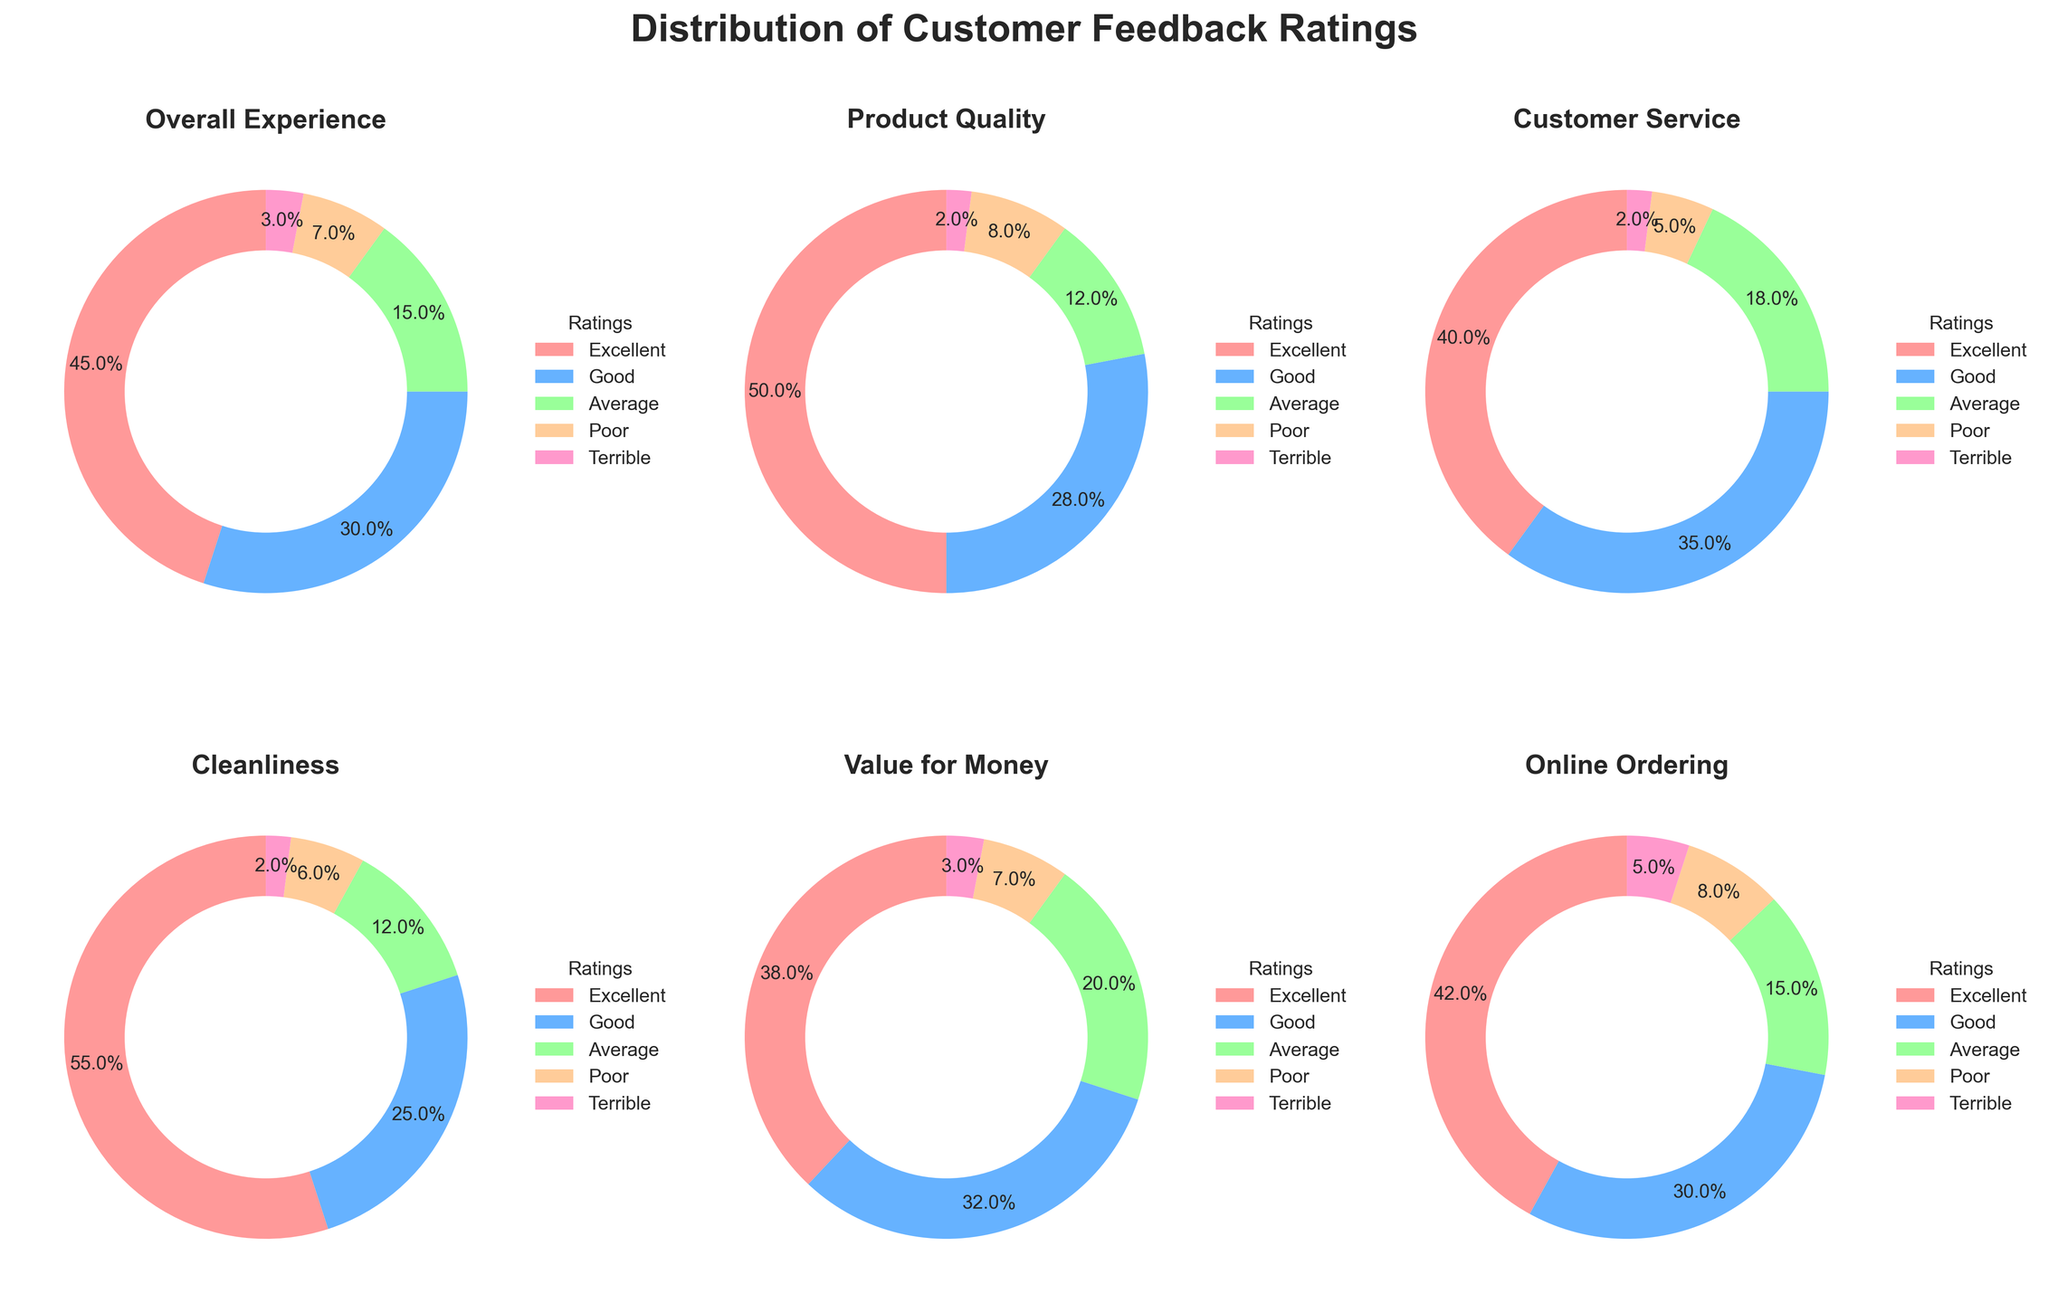How is the distribution of customer feedback for the Overall Experience category? The pie chart for the Overall Experience category shows the distribution of ratings among Excellent, Good, Average, Poor, and Terrible. Excellent comprises 45%, Good comprises 30%, Average comprises 15%, Poor comprises 7%, and Terrible comprises 3%.
Answer: Excellent: 45%, Good: 30%, Average: 15%, Poor: 7%, Terrible: 3% Which category received the highest percentage of Excellent ratings? Looking at the pie charts, Cleanliness received the highest percentage of Excellent ratings at 55%.
Answer: Cleanliness Which category has the most balanced distribution of ratings? By comparing the pie charts, Customer Service seems to have the most balanced distribution with Good (35%) and Excellent (40%) being quite close and the rest as well.
Answer: Customer Service What percentage of Terrible ratings does the Online Ordering category have? The pie chart for Online Ordering shows that Terrible ratings occupy 5%.
Answer: 5% How does Product Quality's percentage of Average ratings compare to Value for Money's? The pie chart shows Product Quality has 12% Average ratings while Value for Money has 20%. So, Value for Money has a higher percentage.
Answer: Product Quality: 12%, Value for Money: 20% Which rating category (Excellent, Good, etc.) appears least in Customer Service? Terrible appears least in Customer Service category with just 2%.
Answer: Terrible: 2% What is the total percentage of Poor ratings across all categories? Summing up the percentages of Poor ratings from all pie charts: Overall Experience (7%), Product Quality (8%), Customer Service (5%), Cleanliness (6%), Value for Money (7%), and Online Ordering (8%). (7 + 8 + 5 + 6 + 7 + 8) = 41%
Answer: 41% How do the Good ratings compare between Overall Experience and Cleanliness? From the pie charts, Overall Experience has 30% Good ratings while Cleanliness has 25%. So, Overall Experience has a higher percentage.
Answer: Overall Experience: 30%, Cleanliness: 25% In which category do the Poor and Terrible ratings combined exceed 10%? Looking at the Poor and Terrible ratings together: Overall Experience (10%), Product Quality (10%), Customer Service (7%), Cleanliness (8%), Value for Money (10%), and Online Ordering (13%). Online Ordering exceeds 10% with a total of 13%.
Answer: Online Ordering Which category has the second highest percentage of Good ratings? Upon examining the pie charts, Customer Service has the highest Good ratings (35%), followed by Value for Money with 32%.
Answer: Value for Money 